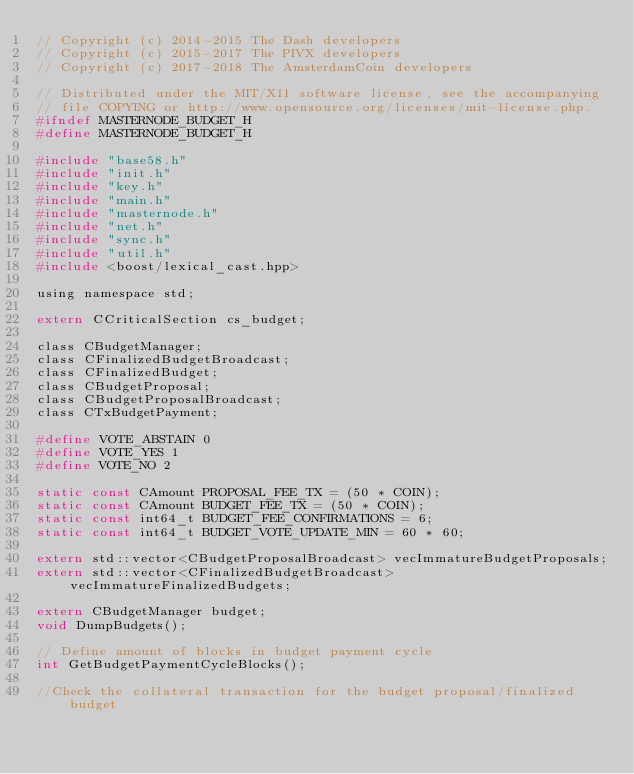Convert code to text. <code><loc_0><loc_0><loc_500><loc_500><_C_>// Copyright (c) 2014-2015 The Dash developers
// Copyright (c) 2015-2017 The PIVX developers
// Copyright (c) 2017-2018 The AmsterdamCoin developers

// Distributed under the MIT/X11 software license, see the accompanying
// file COPYING or http://www.opensource.org/licenses/mit-license.php.
#ifndef MASTERNODE_BUDGET_H
#define MASTERNODE_BUDGET_H

#include "base58.h"
#include "init.h"
#include "key.h"
#include "main.h"
#include "masternode.h"
#include "net.h"
#include "sync.h"
#include "util.h"
#include <boost/lexical_cast.hpp>

using namespace std;

extern CCriticalSection cs_budget;

class CBudgetManager;
class CFinalizedBudgetBroadcast;
class CFinalizedBudget;
class CBudgetProposal;
class CBudgetProposalBroadcast;
class CTxBudgetPayment;

#define VOTE_ABSTAIN 0
#define VOTE_YES 1
#define VOTE_NO 2

static const CAmount PROPOSAL_FEE_TX = (50 * COIN);
static const CAmount BUDGET_FEE_TX = (50 * COIN);
static const int64_t BUDGET_FEE_CONFIRMATIONS = 6;
static const int64_t BUDGET_VOTE_UPDATE_MIN = 60 * 60;

extern std::vector<CBudgetProposalBroadcast> vecImmatureBudgetProposals;
extern std::vector<CFinalizedBudgetBroadcast> vecImmatureFinalizedBudgets;

extern CBudgetManager budget;
void DumpBudgets();

// Define amount of blocks in budget payment cycle
int GetBudgetPaymentCycleBlocks();

//Check the collateral transaction for the budget proposal/finalized budget</code> 